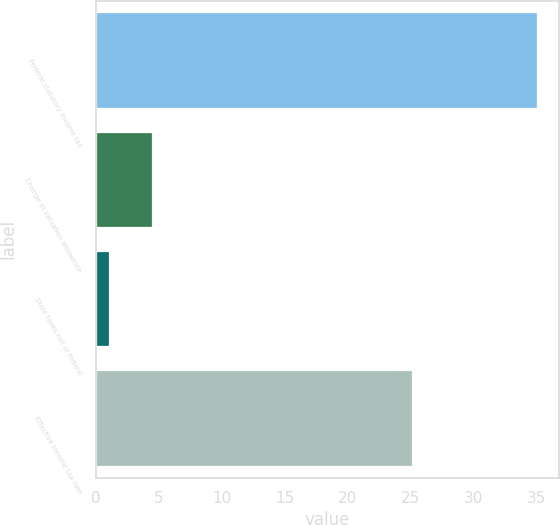Convert chart to OTSL. <chart><loc_0><loc_0><loc_500><loc_500><bar_chart><fcel>Federal statutory income tax<fcel>Change in valuation allowance<fcel>State taxes net of federal<fcel>Effective income tax rate<nl><fcel>35<fcel>4.49<fcel>1.1<fcel>25.1<nl></chart> 